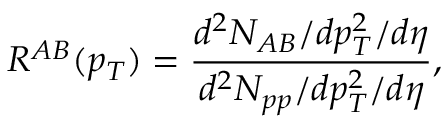Convert formula to latex. <formula><loc_0><loc_0><loc_500><loc_500>R ^ { A B } ( p _ { T } ) = \frac { d ^ { 2 } N _ { A B } / d p _ { T } ^ { 2 } / d \eta } { d ^ { 2 } N _ { p p } / d p _ { T } ^ { 2 } / d \eta } ,</formula> 